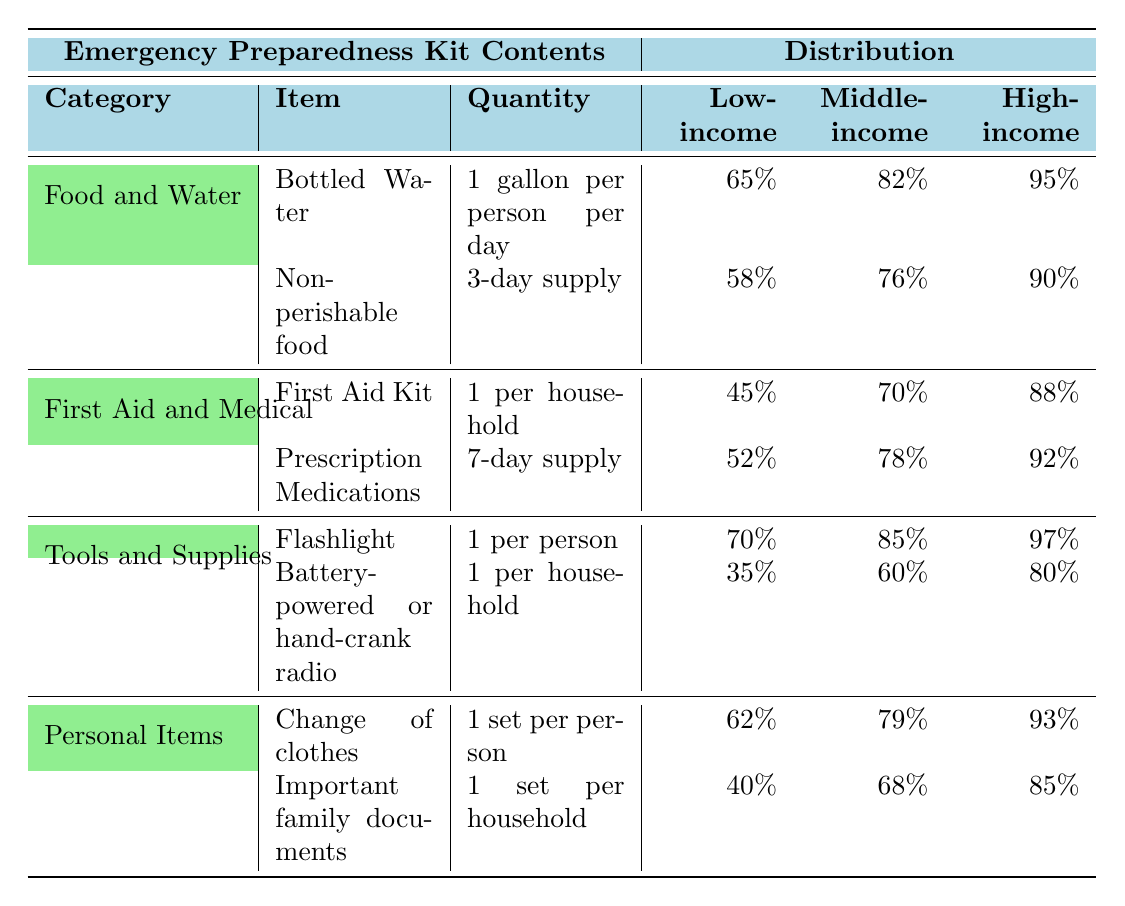What percentage of low-income families have a first aid kit? The table shows that 45% of low-income families have a first aid kit in the "First Aid and Medical" category.
Answer: 45% Which item has the highest distribution among high-income families? In the table, "Bottled Water" has a distribution of 95% among high-income families, which is the highest percentage compared to other items listed.
Answer: Bottled Water What is the percentage difference in distribution of non-perishable food between low-income and high-income families? Low-income families have 58% with non-perishable food, and high-income families have 90%. The difference is 90% - 58% = 32%.
Answer: 32% Do more middle-income families have prescription medications or a first aid kit? The table indicates that 78% of middle-income families have prescription medications and 70% have a first aid kit. Since 78% is greater than 70%, more middle-income families have prescription medications.
Answer: Yes What is the average percentage of distribution for all items among low-income families? For low-income families, the percentages are: Bottled Water (65%), Non-perishable food (58%), First Aid Kit (45%), Prescription Medications (52%), Flashlight (70%), Battery-powered radio (35%), Change of clothes (62%), and Important documents (40%). Calculate the average: (65 + 58 + 45 + 52 + 70 + 35 + 62 + 40) / 8 = 52.5%.
Answer: 52.5% Which category has the lowest item distribution for low-income families? The "Tools and Supplies" category has the lowest distribution for the item "Battery-powered or hand-crank radio" at 35%, lower than all other items for low-income families.
Answer: Tools and Supplies How does the distribution of important family documents for middle-income families compare to that of low-income families? Middle-income families have 68% for important family documents, while low-income families have 40%. The middle-income families' distribution is greater by 28%.
Answer: 28% What item shows the least distribution among high-income families? The table indicates that "Battery-powered or hand-crank radio" has 80% distribution among high-income families, which is the least compared to other high-income family item distributions listed.
Answer: Battery-powered or hand-crank radio 